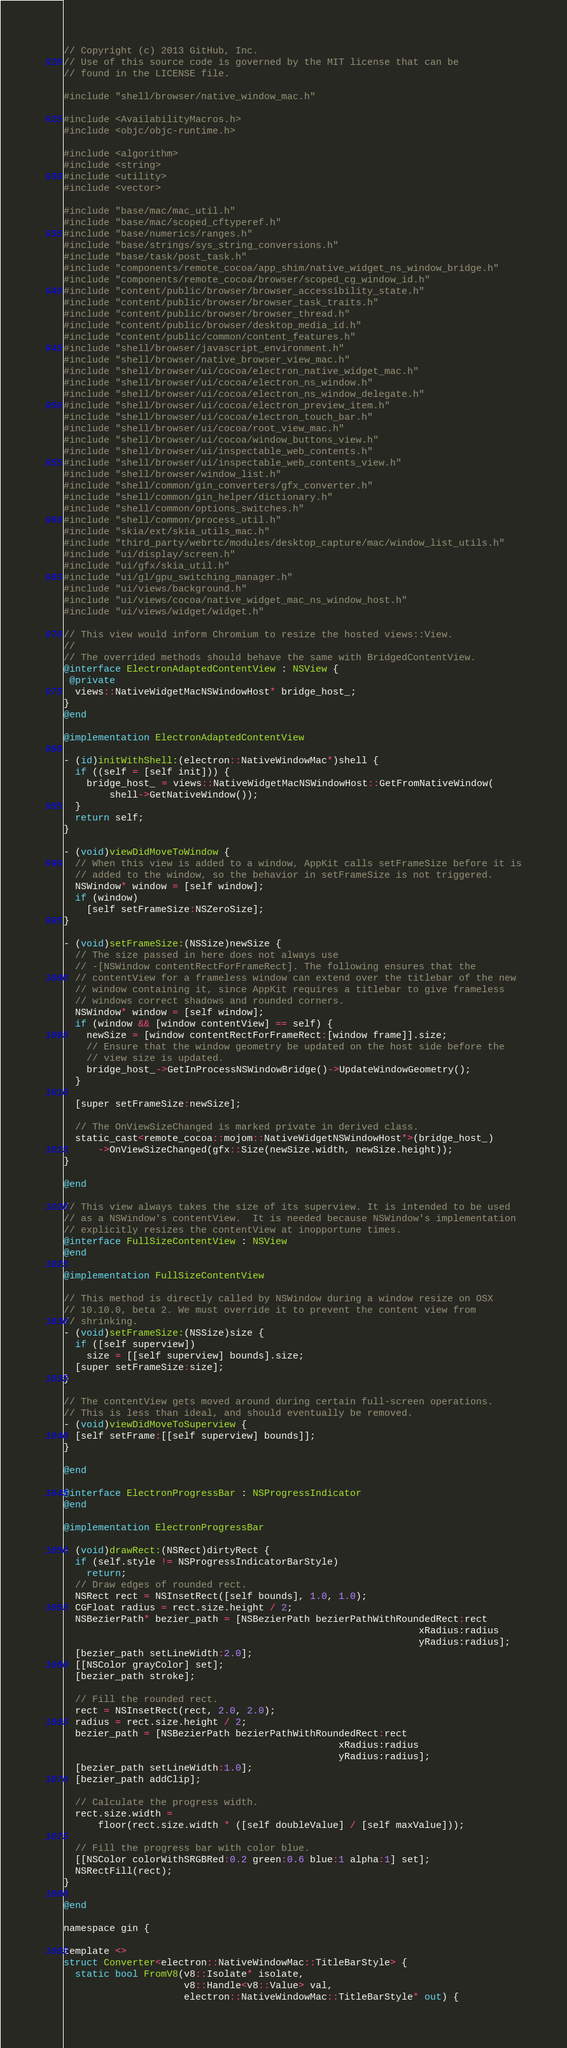<code> <loc_0><loc_0><loc_500><loc_500><_ObjectiveC_>// Copyright (c) 2013 GitHub, Inc.
// Use of this source code is governed by the MIT license that can be
// found in the LICENSE file.

#include "shell/browser/native_window_mac.h"

#include <AvailabilityMacros.h>
#include <objc/objc-runtime.h>

#include <algorithm>
#include <string>
#include <utility>
#include <vector>

#include "base/mac/mac_util.h"
#include "base/mac/scoped_cftyperef.h"
#include "base/numerics/ranges.h"
#include "base/strings/sys_string_conversions.h"
#include "base/task/post_task.h"
#include "components/remote_cocoa/app_shim/native_widget_ns_window_bridge.h"
#include "components/remote_cocoa/browser/scoped_cg_window_id.h"
#include "content/public/browser/browser_accessibility_state.h"
#include "content/public/browser/browser_task_traits.h"
#include "content/public/browser/browser_thread.h"
#include "content/public/browser/desktop_media_id.h"
#include "content/public/common/content_features.h"
#include "shell/browser/javascript_environment.h"
#include "shell/browser/native_browser_view_mac.h"
#include "shell/browser/ui/cocoa/electron_native_widget_mac.h"
#include "shell/browser/ui/cocoa/electron_ns_window.h"
#include "shell/browser/ui/cocoa/electron_ns_window_delegate.h"
#include "shell/browser/ui/cocoa/electron_preview_item.h"
#include "shell/browser/ui/cocoa/electron_touch_bar.h"
#include "shell/browser/ui/cocoa/root_view_mac.h"
#include "shell/browser/ui/cocoa/window_buttons_view.h"
#include "shell/browser/ui/inspectable_web_contents.h"
#include "shell/browser/ui/inspectable_web_contents_view.h"
#include "shell/browser/window_list.h"
#include "shell/common/gin_converters/gfx_converter.h"
#include "shell/common/gin_helper/dictionary.h"
#include "shell/common/options_switches.h"
#include "shell/common/process_util.h"
#include "skia/ext/skia_utils_mac.h"
#include "third_party/webrtc/modules/desktop_capture/mac/window_list_utils.h"
#include "ui/display/screen.h"
#include "ui/gfx/skia_util.h"
#include "ui/gl/gpu_switching_manager.h"
#include "ui/views/background.h"
#include "ui/views/cocoa/native_widget_mac_ns_window_host.h"
#include "ui/views/widget/widget.h"

// This view would inform Chromium to resize the hosted views::View.
//
// The overrided methods should behave the same with BridgedContentView.
@interface ElectronAdaptedContentView : NSView {
 @private
  views::NativeWidgetMacNSWindowHost* bridge_host_;
}
@end

@implementation ElectronAdaptedContentView

- (id)initWithShell:(electron::NativeWindowMac*)shell {
  if ((self = [self init])) {
    bridge_host_ = views::NativeWidgetMacNSWindowHost::GetFromNativeWindow(
        shell->GetNativeWindow());
  }
  return self;
}

- (void)viewDidMoveToWindow {
  // When this view is added to a window, AppKit calls setFrameSize before it is
  // added to the window, so the behavior in setFrameSize is not triggered.
  NSWindow* window = [self window];
  if (window)
    [self setFrameSize:NSZeroSize];
}

- (void)setFrameSize:(NSSize)newSize {
  // The size passed in here does not always use
  // -[NSWindow contentRectForFrameRect]. The following ensures that the
  // contentView for a frameless window can extend over the titlebar of the new
  // window containing it, since AppKit requires a titlebar to give frameless
  // windows correct shadows and rounded corners.
  NSWindow* window = [self window];
  if (window && [window contentView] == self) {
    newSize = [window contentRectForFrameRect:[window frame]].size;
    // Ensure that the window geometry be updated on the host side before the
    // view size is updated.
    bridge_host_->GetInProcessNSWindowBridge()->UpdateWindowGeometry();
  }

  [super setFrameSize:newSize];

  // The OnViewSizeChanged is marked private in derived class.
  static_cast<remote_cocoa::mojom::NativeWidgetNSWindowHost*>(bridge_host_)
      ->OnViewSizeChanged(gfx::Size(newSize.width, newSize.height));
}

@end

// This view always takes the size of its superview. It is intended to be used
// as a NSWindow's contentView.  It is needed because NSWindow's implementation
// explicitly resizes the contentView at inopportune times.
@interface FullSizeContentView : NSView
@end

@implementation FullSizeContentView

// This method is directly called by NSWindow during a window resize on OSX
// 10.10.0, beta 2. We must override it to prevent the content view from
// shrinking.
- (void)setFrameSize:(NSSize)size {
  if ([self superview])
    size = [[self superview] bounds].size;
  [super setFrameSize:size];
}

// The contentView gets moved around during certain full-screen operations.
// This is less than ideal, and should eventually be removed.
- (void)viewDidMoveToSuperview {
  [self setFrame:[[self superview] bounds]];
}

@end

@interface ElectronProgressBar : NSProgressIndicator
@end

@implementation ElectronProgressBar

- (void)drawRect:(NSRect)dirtyRect {
  if (self.style != NSProgressIndicatorBarStyle)
    return;
  // Draw edges of rounded rect.
  NSRect rect = NSInsetRect([self bounds], 1.0, 1.0);
  CGFloat radius = rect.size.height / 2;
  NSBezierPath* bezier_path = [NSBezierPath bezierPathWithRoundedRect:rect
                                                              xRadius:radius
                                                              yRadius:radius];
  [bezier_path setLineWidth:2.0];
  [[NSColor grayColor] set];
  [bezier_path stroke];

  // Fill the rounded rect.
  rect = NSInsetRect(rect, 2.0, 2.0);
  radius = rect.size.height / 2;
  bezier_path = [NSBezierPath bezierPathWithRoundedRect:rect
                                                xRadius:radius
                                                yRadius:radius];
  [bezier_path setLineWidth:1.0];
  [bezier_path addClip];

  // Calculate the progress width.
  rect.size.width =
      floor(rect.size.width * ([self doubleValue] / [self maxValue]));

  // Fill the progress bar with color blue.
  [[NSColor colorWithSRGBRed:0.2 green:0.6 blue:1 alpha:1] set];
  NSRectFill(rect);
}

@end

namespace gin {

template <>
struct Converter<electron::NativeWindowMac::TitleBarStyle> {
  static bool FromV8(v8::Isolate* isolate,
                     v8::Handle<v8::Value> val,
                     electron::NativeWindowMac::TitleBarStyle* out) {</code> 